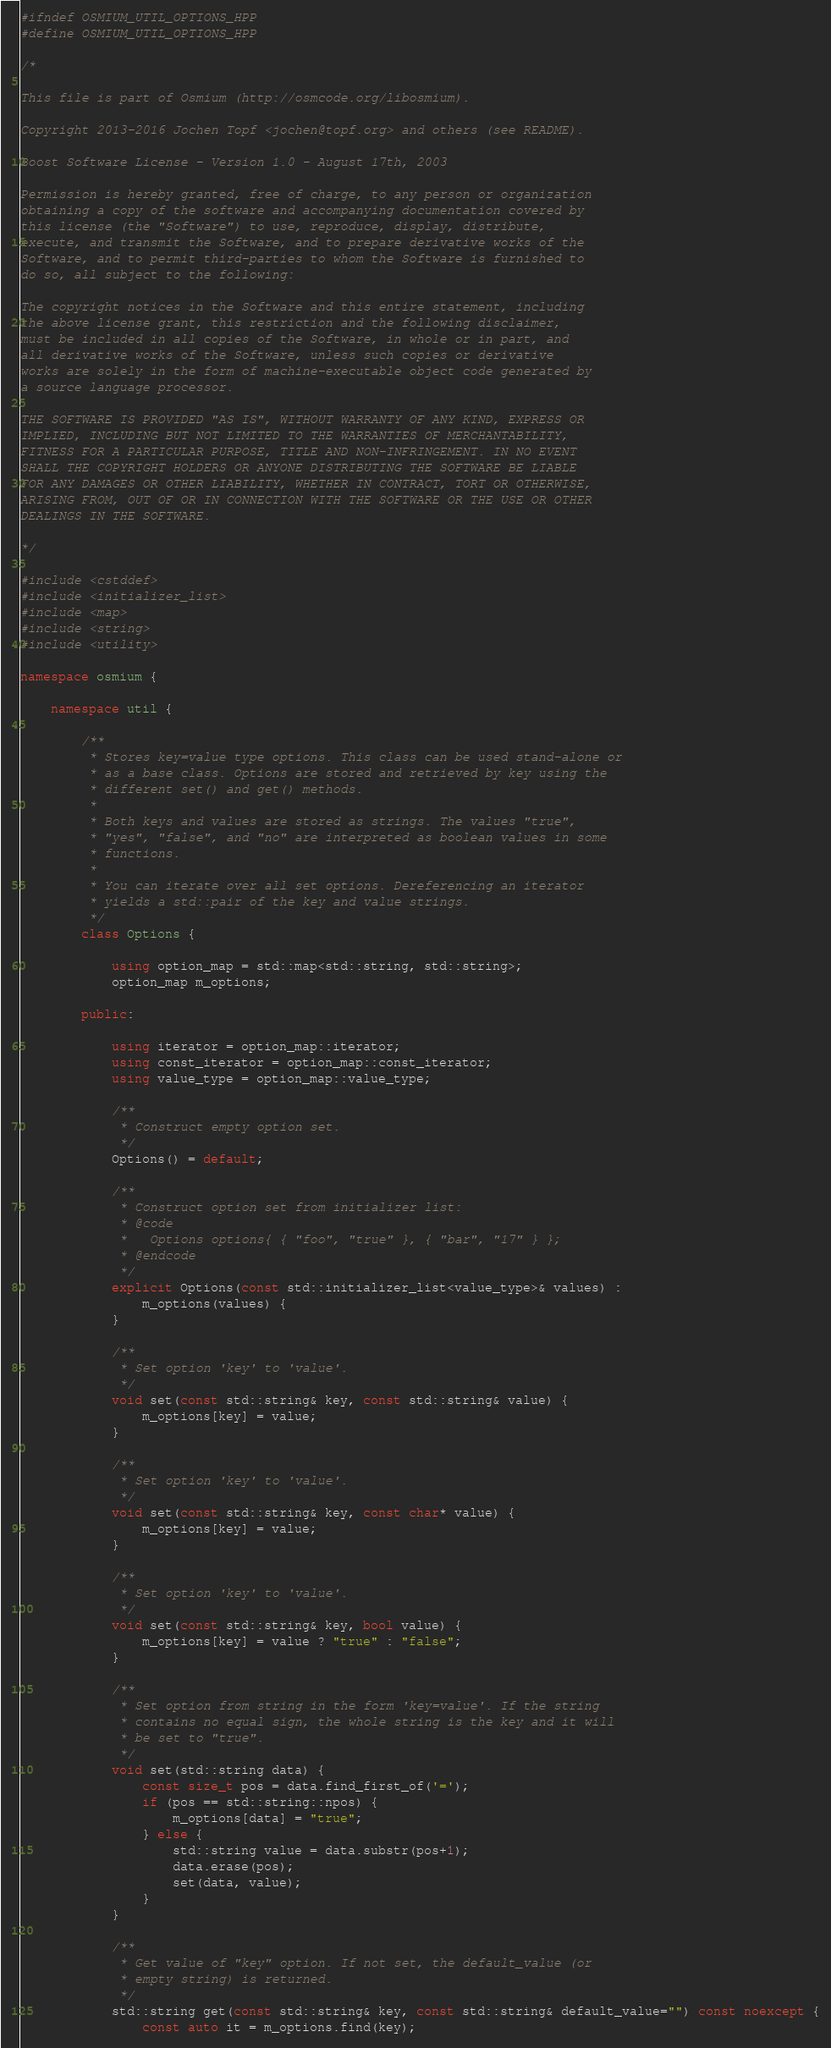<code> <loc_0><loc_0><loc_500><loc_500><_C++_>#ifndef OSMIUM_UTIL_OPTIONS_HPP
#define OSMIUM_UTIL_OPTIONS_HPP

/*

This file is part of Osmium (http://osmcode.org/libosmium).

Copyright 2013-2016 Jochen Topf <jochen@topf.org> and others (see README).

Boost Software License - Version 1.0 - August 17th, 2003

Permission is hereby granted, free of charge, to any person or organization
obtaining a copy of the software and accompanying documentation covered by
this license (the "Software") to use, reproduce, display, distribute,
execute, and transmit the Software, and to prepare derivative works of the
Software, and to permit third-parties to whom the Software is furnished to
do so, all subject to the following:

The copyright notices in the Software and this entire statement, including
the above license grant, this restriction and the following disclaimer,
must be included in all copies of the Software, in whole or in part, and
all derivative works of the Software, unless such copies or derivative
works are solely in the form of machine-executable object code generated by
a source language processor.

THE SOFTWARE IS PROVIDED "AS IS", WITHOUT WARRANTY OF ANY KIND, EXPRESS OR
IMPLIED, INCLUDING BUT NOT LIMITED TO THE WARRANTIES OF MERCHANTABILITY,
FITNESS FOR A PARTICULAR PURPOSE, TITLE AND NON-INFRINGEMENT. IN NO EVENT
SHALL THE COPYRIGHT HOLDERS OR ANYONE DISTRIBUTING THE SOFTWARE BE LIABLE
FOR ANY DAMAGES OR OTHER LIABILITY, WHETHER IN CONTRACT, TORT OR OTHERWISE,
ARISING FROM, OUT OF OR IN CONNECTION WITH THE SOFTWARE OR THE USE OR OTHER
DEALINGS IN THE SOFTWARE.

*/

#include <cstddef>
#include <initializer_list>
#include <map>
#include <string>
#include <utility>

namespace osmium {

    namespace util {

        /**
         * Stores key=value type options. This class can be used stand-alone or
         * as a base class. Options are stored and retrieved by key using the
         * different set() and get() methods.
         *
         * Both keys and values are stored as strings. The values "true",
         * "yes", "false", and "no" are interpreted as boolean values in some
         * functions.
         *
         * You can iterate over all set options. Dereferencing an iterator
         * yields a std::pair of the key and value strings.
         */
        class Options {

            using option_map = std::map<std::string, std::string>;
            option_map m_options;

        public:

            using iterator = option_map::iterator;
            using const_iterator = option_map::const_iterator;
            using value_type = option_map::value_type;

            /**
             * Construct empty option set.
             */
            Options() = default;

            /**
             * Construct option set from initializer list:
             * @code
             *   Options options{ { "foo", "true" }, { "bar", "17" } };
             * @endcode
             */
            explicit Options(const std::initializer_list<value_type>& values) :
                m_options(values) {
            }

            /**
             * Set option 'key' to 'value'.
             */
            void set(const std::string& key, const std::string& value) {
                m_options[key] = value;
            }

            /**
             * Set option 'key' to 'value'.
             */
            void set(const std::string& key, const char* value) {
                m_options[key] = value;
            }

            /**
             * Set option 'key' to 'value'.
             */
            void set(const std::string& key, bool value) {
                m_options[key] = value ? "true" : "false";
            }

            /**
             * Set option from string in the form 'key=value'. If the string
             * contains no equal sign, the whole string is the key and it will
             * be set to "true".
             */
            void set(std::string data) {
                const size_t pos = data.find_first_of('=');
                if (pos == std::string::npos) {
                    m_options[data] = "true";
                } else {
                    std::string value = data.substr(pos+1);
                    data.erase(pos);
                    set(data, value);
                }
            }

            /**
             * Get value of "key" option. If not set, the default_value (or
             * empty string) is returned.
             */
            std::string get(const std::string& key, const std::string& default_value="") const noexcept {
                const auto it = m_options.find(key);</code> 